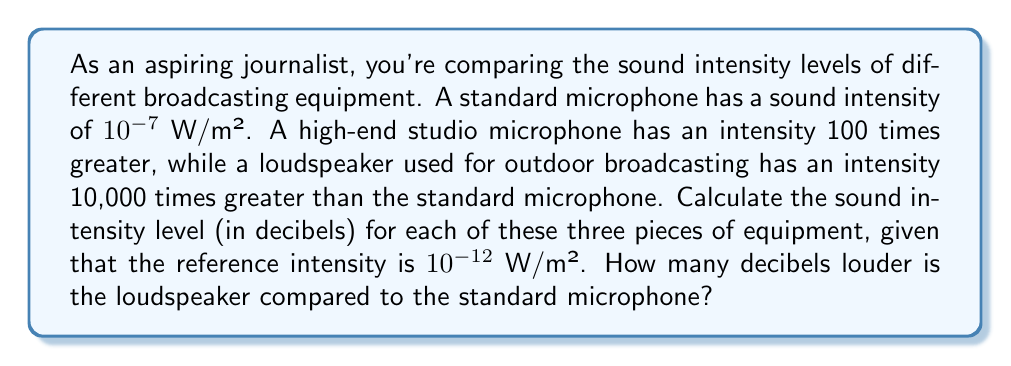Show me your answer to this math problem. Let's approach this step-by-step using the formula for sound intensity level:

$$ \text{Sound Intensity Level (dB)} = 10 \log_{10}\left(\frac{I}{I_0}\right) $$

Where $I$ is the intensity of the sound and $I_0$ is the reference intensity.

1. For the standard microphone:
   $I = 10^{-7}$ W/m², $I_0 = 10^{-12}$ W/m²
   $$ \text{SIL} = 10 \log_{10}\left(\frac{10^{-7}}{10^{-12}}\right) = 10 \log_{10}(10^5) = 10 \cdot 5 = 50 \text{ dB} $$

2. For the high-end studio microphone:
   $I = 100 \cdot 10^{-7} = 10^{-5}$ W/m²
   $$ \text{SIL} = 10 \log_{10}\left(\frac{10^{-5}}{10^{-12}}\right) = 10 \log_{10}(10^7) = 10 \cdot 7 = 70 \text{ dB} $$

3. For the loudspeaker:
   $I = 10000 \cdot 10^{-7} = 10^{-3}$ W/m²
   $$ \text{SIL} = 10 \log_{10}\left(\frac{10^{-3}}{10^{-12}}\right) = 10 \log_{10}(10^9) = 10 \cdot 9 = 90 \text{ dB} $$

4. To find how many decibels louder the loudspeaker is compared to the standard microphone:
   $90 \text{ dB} - 50 \text{ dB} = 40 \text{ dB}$
Answer: Standard microphone: 50 dB, High-end studio microphone: 70 dB, Loudspeaker: 90 dB. The loudspeaker is 40 dB louder than the standard microphone. 